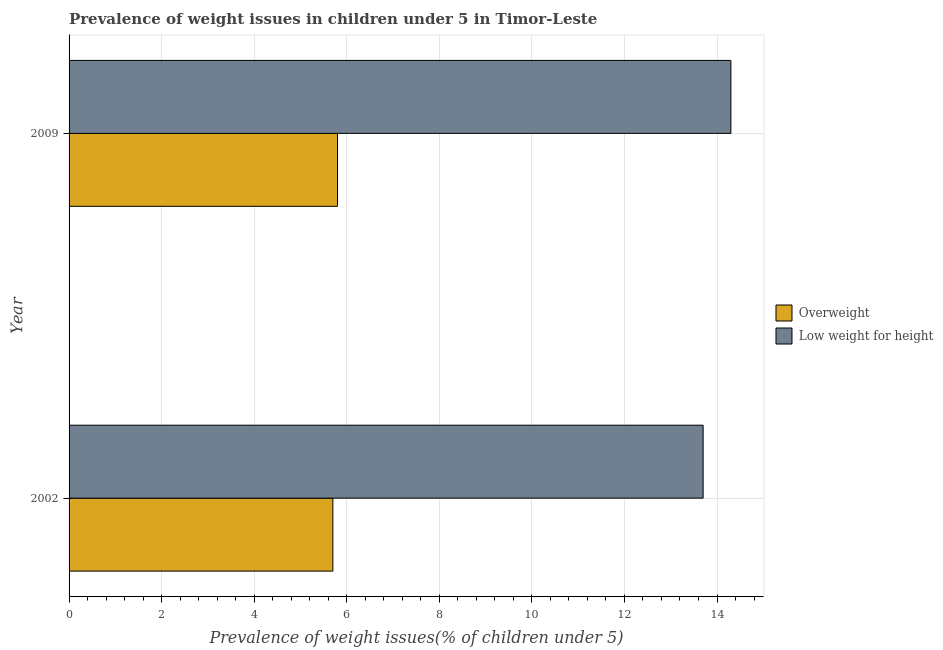Are the number of bars per tick equal to the number of legend labels?
Offer a terse response. Yes. Are the number of bars on each tick of the Y-axis equal?
Your answer should be compact. Yes. How many bars are there on the 2nd tick from the bottom?
Your answer should be compact. 2. What is the percentage of underweight children in 2009?
Your answer should be compact. 14.3. Across all years, what is the maximum percentage of underweight children?
Your response must be concise. 14.3. Across all years, what is the minimum percentage of overweight children?
Offer a terse response. 5.7. What is the total percentage of overweight children in the graph?
Your answer should be very brief. 11.5. What is the difference between the percentage of underweight children in 2009 and the percentage of overweight children in 2002?
Keep it short and to the point. 8.6. What is the ratio of the percentage of underweight children in 2002 to that in 2009?
Offer a terse response. 0.96. Is the difference between the percentage of overweight children in 2002 and 2009 greater than the difference between the percentage of underweight children in 2002 and 2009?
Make the answer very short. Yes. In how many years, is the percentage of overweight children greater than the average percentage of overweight children taken over all years?
Provide a short and direct response. 1. What does the 2nd bar from the top in 2002 represents?
Provide a succinct answer. Overweight. What does the 2nd bar from the bottom in 2009 represents?
Keep it short and to the point. Low weight for height. Are all the bars in the graph horizontal?
Your answer should be very brief. Yes. How many years are there in the graph?
Offer a very short reply. 2. Are the values on the major ticks of X-axis written in scientific E-notation?
Keep it short and to the point. No. Does the graph contain any zero values?
Offer a very short reply. No. Where does the legend appear in the graph?
Make the answer very short. Center right. What is the title of the graph?
Your answer should be very brief. Prevalence of weight issues in children under 5 in Timor-Leste. What is the label or title of the X-axis?
Keep it short and to the point. Prevalence of weight issues(% of children under 5). What is the Prevalence of weight issues(% of children under 5) in Overweight in 2002?
Keep it short and to the point. 5.7. What is the Prevalence of weight issues(% of children under 5) of Low weight for height in 2002?
Ensure brevity in your answer.  13.7. What is the Prevalence of weight issues(% of children under 5) in Overweight in 2009?
Provide a succinct answer. 5.8. What is the Prevalence of weight issues(% of children under 5) of Low weight for height in 2009?
Keep it short and to the point. 14.3. Across all years, what is the maximum Prevalence of weight issues(% of children under 5) in Overweight?
Your answer should be compact. 5.8. Across all years, what is the maximum Prevalence of weight issues(% of children under 5) in Low weight for height?
Make the answer very short. 14.3. Across all years, what is the minimum Prevalence of weight issues(% of children under 5) in Overweight?
Provide a short and direct response. 5.7. Across all years, what is the minimum Prevalence of weight issues(% of children under 5) of Low weight for height?
Keep it short and to the point. 13.7. What is the difference between the Prevalence of weight issues(% of children under 5) in Overweight in 2002 and that in 2009?
Keep it short and to the point. -0.1. What is the difference between the Prevalence of weight issues(% of children under 5) in Low weight for height in 2002 and that in 2009?
Offer a terse response. -0.6. What is the difference between the Prevalence of weight issues(% of children under 5) in Overweight in 2002 and the Prevalence of weight issues(% of children under 5) in Low weight for height in 2009?
Your response must be concise. -8.6. What is the average Prevalence of weight issues(% of children under 5) in Overweight per year?
Your answer should be very brief. 5.75. What is the average Prevalence of weight issues(% of children under 5) in Low weight for height per year?
Your response must be concise. 14. In the year 2009, what is the difference between the Prevalence of weight issues(% of children under 5) of Overweight and Prevalence of weight issues(% of children under 5) of Low weight for height?
Your answer should be compact. -8.5. What is the ratio of the Prevalence of weight issues(% of children under 5) in Overweight in 2002 to that in 2009?
Provide a short and direct response. 0.98. What is the ratio of the Prevalence of weight issues(% of children under 5) of Low weight for height in 2002 to that in 2009?
Offer a very short reply. 0.96. What is the difference between the highest and the second highest Prevalence of weight issues(% of children under 5) of Low weight for height?
Your response must be concise. 0.6. What is the difference between the highest and the lowest Prevalence of weight issues(% of children under 5) of Overweight?
Offer a terse response. 0.1. What is the difference between the highest and the lowest Prevalence of weight issues(% of children under 5) in Low weight for height?
Give a very brief answer. 0.6. 